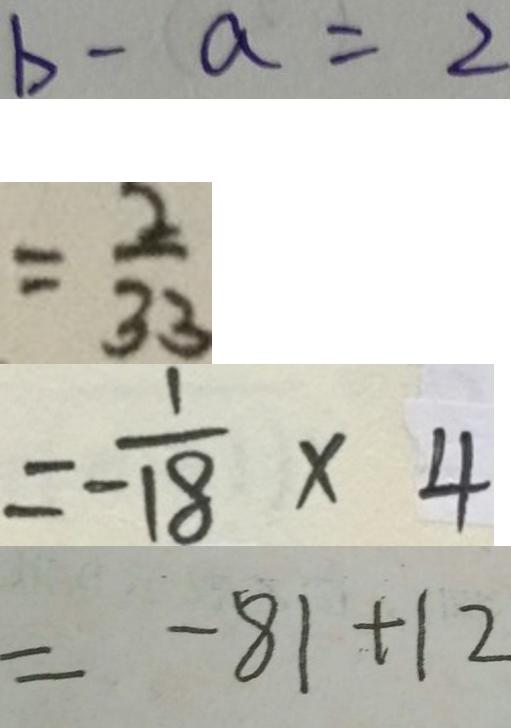<formula> <loc_0><loc_0><loc_500><loc_500>b - a = 2 
 = \frac { 2 } { 3 3 } 
 = - \frac { 1 } { 1 8 } \times 4 
 = - 8 1 + 1 2</formula> 